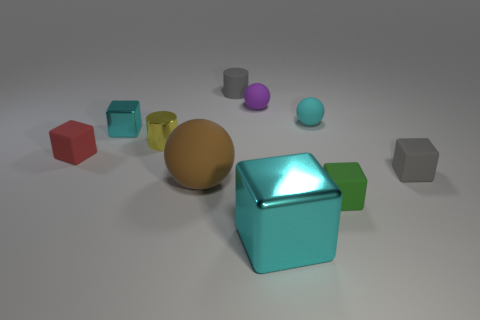Subtract all small matte balls. How many balls are left? 1 Subtract all cyan spheres. How many spheres are left? 2 Subtract all green balls. How many cyan blocks are left? 2 Subtract all cylinders. How many objects are left? 8 Subtract 2 balls. How many balls are left? 1 Subtract all red spheres. Subtract all cyan blocks. How many spheres are left? 3 Subtract all red blocks. Subtract all small gray blocks. How many objects are left? 8 Add 6 yellow objects. How many yellow objects are left? 7 Add 1 big red matte spheres. How many big red matte spheres exist? 1 Subtract 1 brown spheres. How many objects are left? 9 